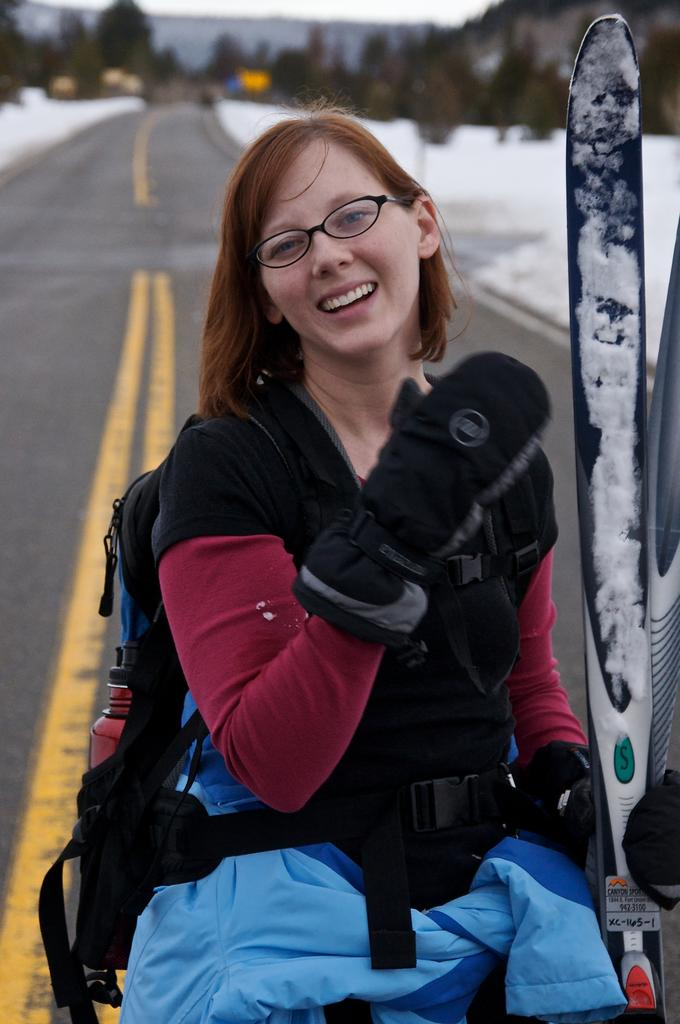Who is present in the image? There is a woman in the image. What is the woman wearing? The woman is wearing a bag. What is the woman holding in the image? The woman is holding a surfboard. What can be seen in the background of the image? There are trees in the background of the image. How would you describe the background in the image? The background is slightly blurred. What type of pie is the woman eating in the image? There is no pie present in the image. 